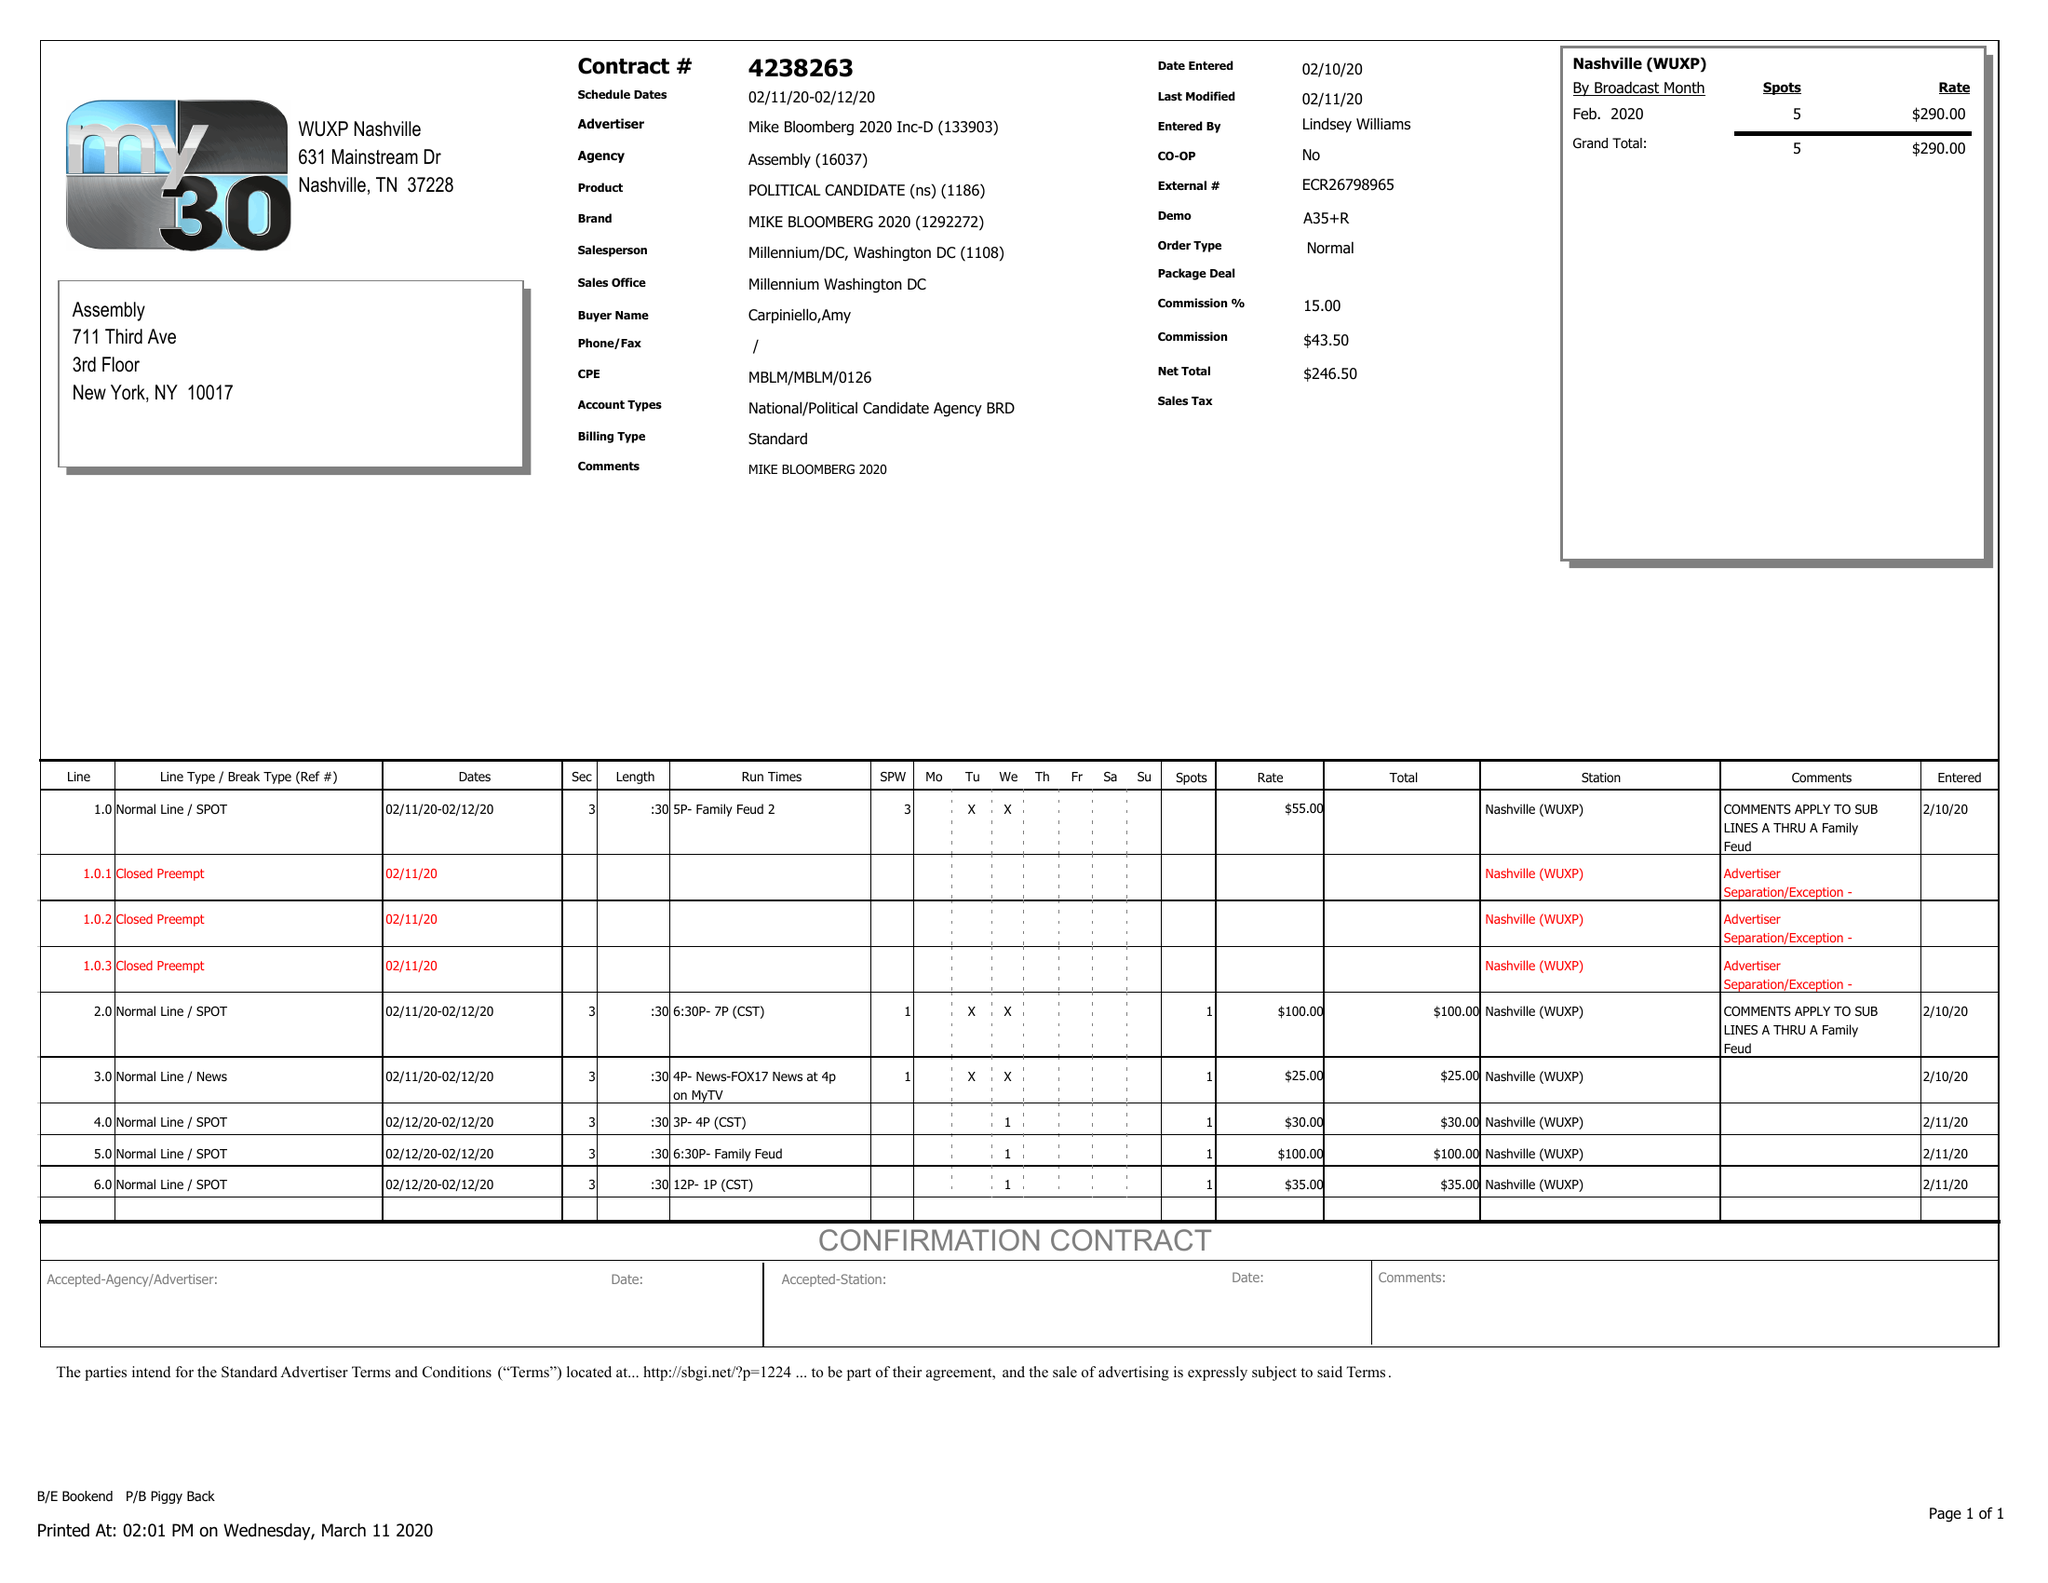What is the value for the flight_from?
Answer the question using a single word or phrase. 02/11/20 